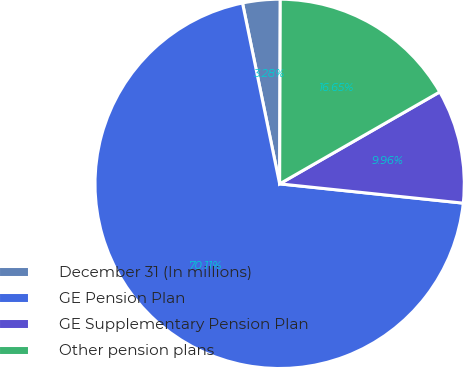Convert chart to OTSL. <chart><loc_0><loc_0><loc_500><loc_500><pie_chart><fcel>December 31 (In millions)<fcel>GE Pension Plan<fcel>GE Supplementary Pension Plan<fcel>Other pension plans<nl><fcel>3.28%<fcel>70.11%<fcel>9.96%<fcel>16.65%<nl></chart> 